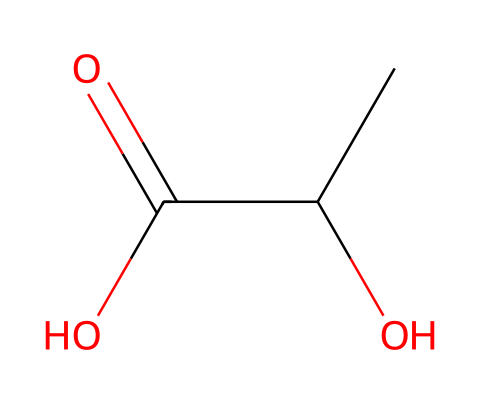What is the molecular formula of lactic acid? The molecular formula can be determined by counting the carbon (C), hydrogen (H), and oxygen (O) atoms in the SMILES representation CC(O)C(=O)O. There are 3 carbon atoms, 6 hydrogen atoms, and 3 oxygen atoms, giving the molecular formula C3H6O3.
Answer: C3H6O3 How many hydroxyl (-OH) groups are present in lactic acid? By examining the SMILES representation, we see one hydroxyl (-OH) group attached to the second carbon (C) in the chain (CC(O)).
Answer: 1 What type of isomerism might lactic acid exhibit? Since lactic acid has a chiral center at the second carbon atom where the hydroxyl group is attached, it exhibits optical isomerism. Optical isomers (enantiomers) are non-superimposable mirror images of each other.
Answer: optical isomerism How many hydrogen atoms are attached to the central carbon? In lactic acid, the central carbon (the second carbon in the chain from the left) is attached to one hydroxyl group, one carboxylic acid group, and one carbon, leaving one hydrogen attached.
Answer: 1 What functional groups are present in lactic acid? The SMILES representation shows both a carboxylic acid group (C(=O)O) and a hydroxyl group (OH), indicating that lactic acid contains these two functional groups.
Answer: carboxylic acid and hydroxyl group What hybridization state is the central carbon in lactic acid? The central carbon in lactic acid is connected to three different substituents (the hydroxyl group, the carboxylic group, and another carbon). This arrangement leads to a tetrahedral geometry, which corresponds to an sp3 hybridization state.
Answer: sp3 